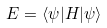Convert formula to latex. <formula><loc_0><loc_0><loc_500><loc_500>E = \langle \psi | H | \psi \rangle</formula> 